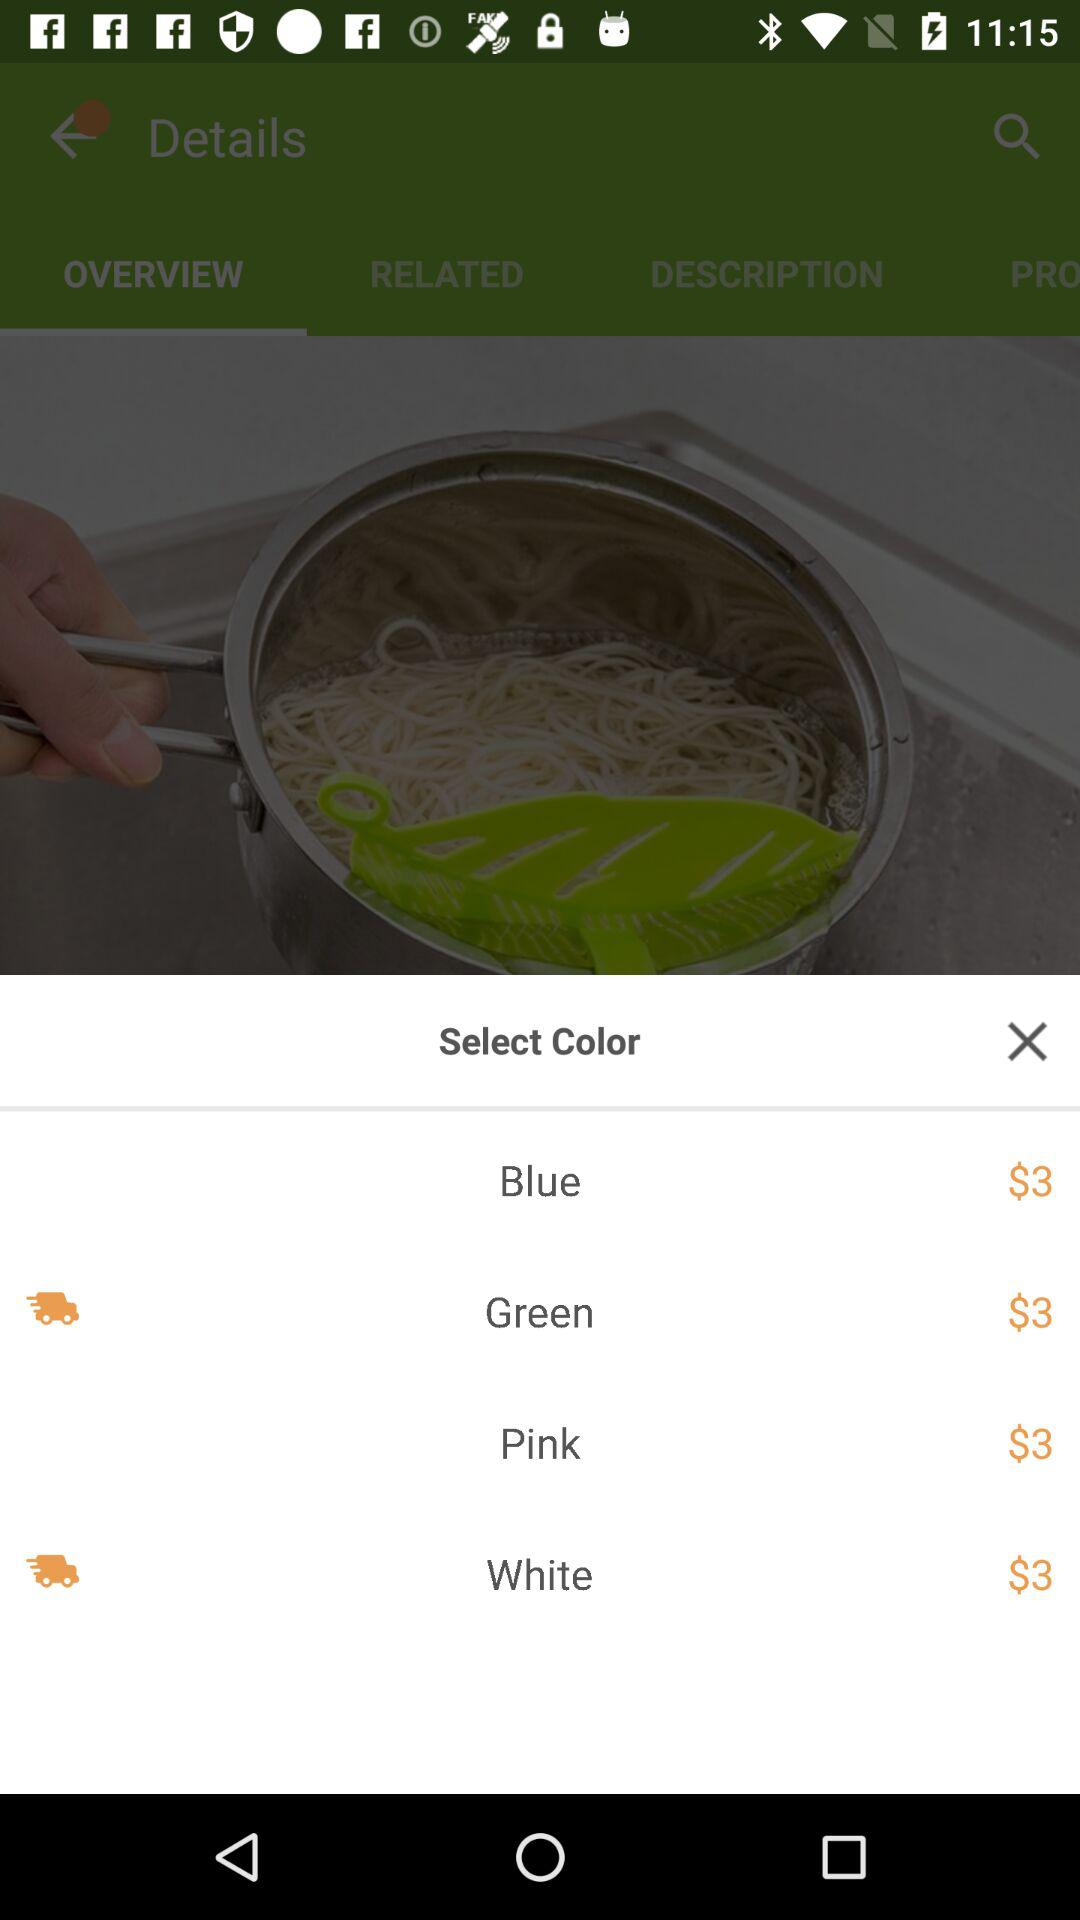How many colors are available for this product?
Answer the question using a single word or phrase. 4 